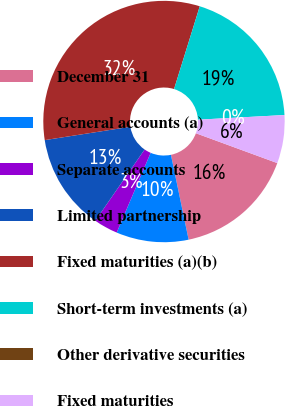Convert chart to OTSL. <chart><loc_0><loc_0><loc_500><loc_500><pie_chart><fcel>December 31<fcel>General accounts (a)<fcel>Separate accounts<fcel>Limited partnership<fcel>Fixed maturities (a)(b)<fcel>Short-term investments (a)<fcel>Other derivative securities<fcel>Fixed maturities<nl><fcel>16.13%<fcel>9.68%<fcel>3.23%<fcel>12.9%<fcel>32.25%<fcel>19.35%<fcel>0.0%<fcel>6.45%<nl></chart> 